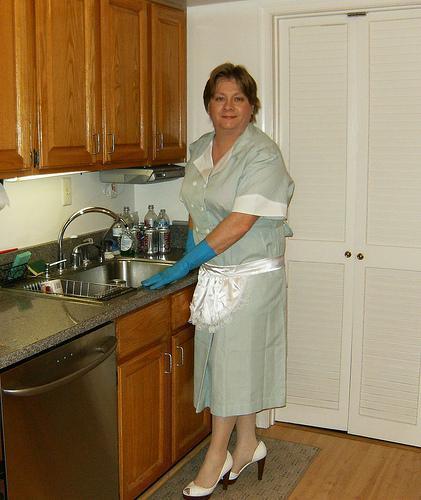How many people are in the picture?
Give a very brief answer. 1. 